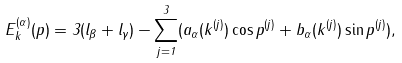Convert formula to latex. <formula><loc_0><loc_0><loc_500><loc_500>E ^ { ( \alpha ) } _ { k } ( p ) = 3 ( l _ { \beta } + l _ { \gamma } ) - \sum _ { j = 1 } ^ { 3 } ( a _ { \alpha } ( k ^ { ( j ) } ) \cos p ^ { ( j ) } + b _ { \alpha } ( k ^ { ( j ) } ) \sin p ^ { ( j ) } ) ,</formula> 